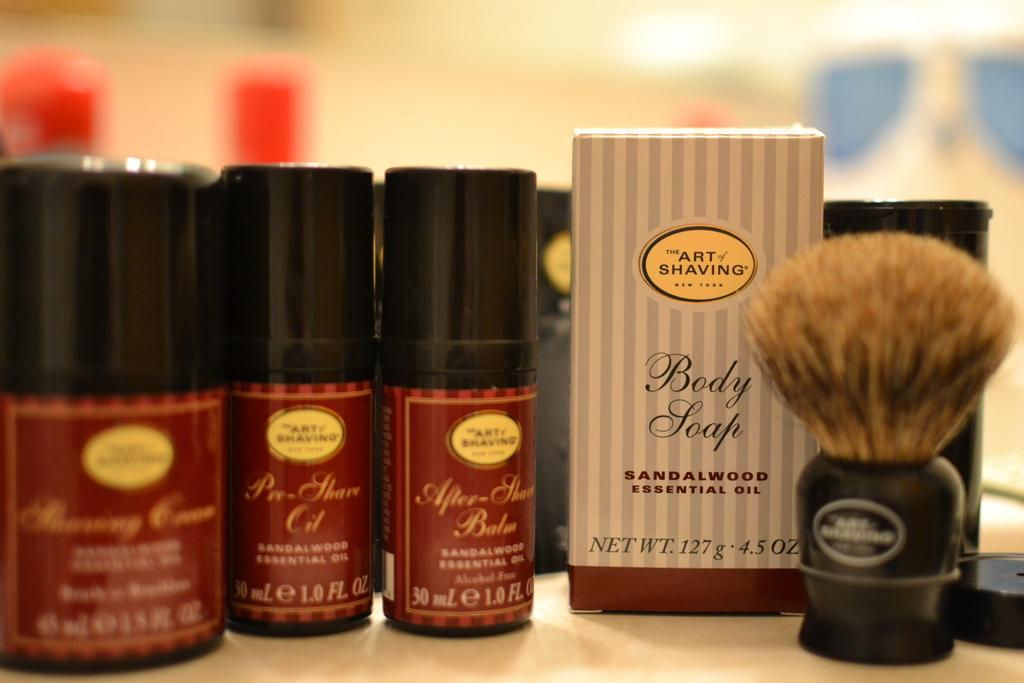<image>
Create a compact narrative representing the image presented. The Art of Shaving products with sandalwood essential oils next to a brush. 